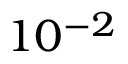<formula> <loc_0><loc_0><loc_500><loc_500>1 0 ^ { - 2 }</formula> 